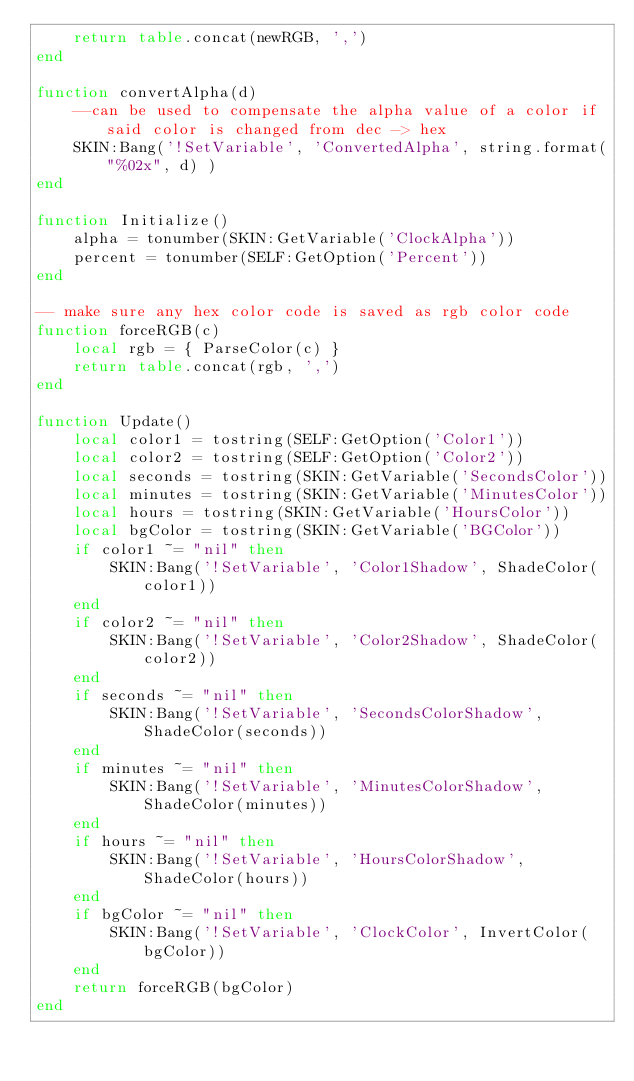Convert code to text. <code><loc_0><loc_0><loc_500><loc_500><_Lua_>    return table.concat(newRGB, ',')
end

function convertAlpha(d)
    --can be used to compensate the alpha value of a color if said color is changed from dec -> hex
    SKIN:Bang('!SetVariable', 'ConvertedAlpha', string.format("%02x", d) )
end

function Initialize()
    alpha = tonumber(SKIN:GetVariable('ClockAlpha'))
    percent = tonumber(SELF:GetOption('Percent'))
end

-- make sure any hex color code is saved as rgb color code
function forceRGB(c)
    local rgb = { ParseColor(c) }
    return table.concat(rgb, ',')
end

function Update()
    local color1 = tostring(SELF:GetOption('Color1'))
    local color2 = tostring(SELF:GetOption('Color2'))
    local seconds = tostring(SKIN:GetVariable('SecondsColor'))
    local minutes = tostring(SKIN:GetVariable('MinutesColor'))
    local hours = tostring(SKIN:GetVariable('HoursColor'))
    local bgColor = tostring(SKIN:GetVariable('BGColor'))
    if color1 ~= "nil" then
        SKIN:Bang('!SetVariable', 'Color1Shadow', ShadeColor(color1))
    end
    if color2 ~= "nil" then
        SKIN:Bang('!SetVariable', 'Color2Shadow', ShadeColor(color2))
    end
    if seconds ~= "nil" then
        SKIN:Bang('!SetVariable', 'SecondsColorShadow', ShadeColor(seconds))
    end
    if minutes ~= "nil" then
        SKIN:Bang('!SetVariable', 'MinutesColorShadow', ShadeColor(minutes))
    end
    if hours ~= "nil" then
        SKIN:Bang('!SetVariable', 'HoursColorShadow', ShadeColor(hours))
    end
    if bgColor ~= "nil" then
        SKIN:Bang('!SetVariable', 'ClockColor', InvertColor(bgColor))
    end
    return forceRGB(bgColor)
end
</code> 